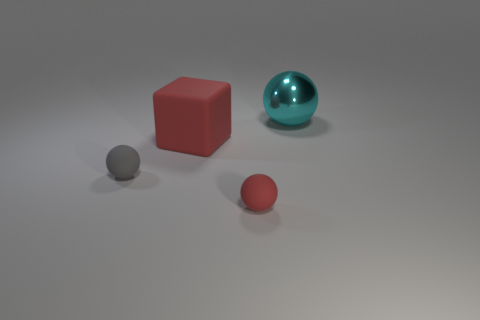Subtract all small rubber balls. How many balls are left? 1 Subtract all red spheres. How many spheres are left? 2 Subtract 1 cubes. How many cubes are left? 0 Add 1 red balls. How many red balls exist? 2 Add 1 tiny yellow shiny spheres. How many objects exist? 5 Subtract 0 green cylinders. How many objects are left? 4 Subtract all blocks. How many objects are left? 3 Subtract all green spheres. Subtract all yellow cubes. How many spheres are left? 3 Subtract all brown cylinders. How many cyan balls are left? 1 Subtract all big green metallic cylinders. Subtract all large cyan spheres. How many objects are left? 3 